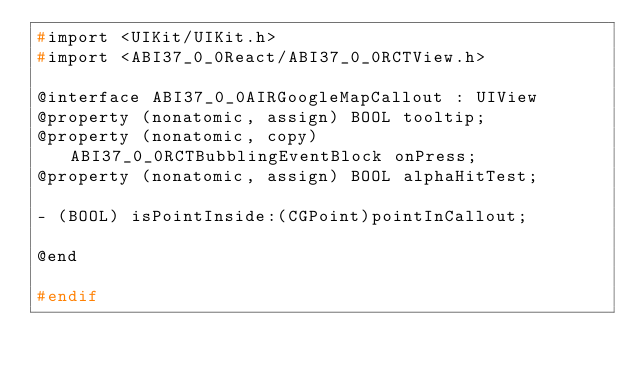Convert code to text. <code><loc_0><loc_0><loc_500><loc_500><_C_>#import <UIKit/UIKit.h>
#import <ABI37_0_0React/ABI37_0_0RCTView.h>

@interface ABI37_0_0AIRGoogleMapCallout : UIView
@property (nonatomic, assign) BOOL tooltip;
@property (nonatomic, copy) ABI37_0_0RCTBubblingEventBlock onPress;
@property (nonatomic, assign) BOOL alphaHitTest;

- (BOOL) isPointInside:(CGPoint)pointInCallout;

@end

#endif
</code> 